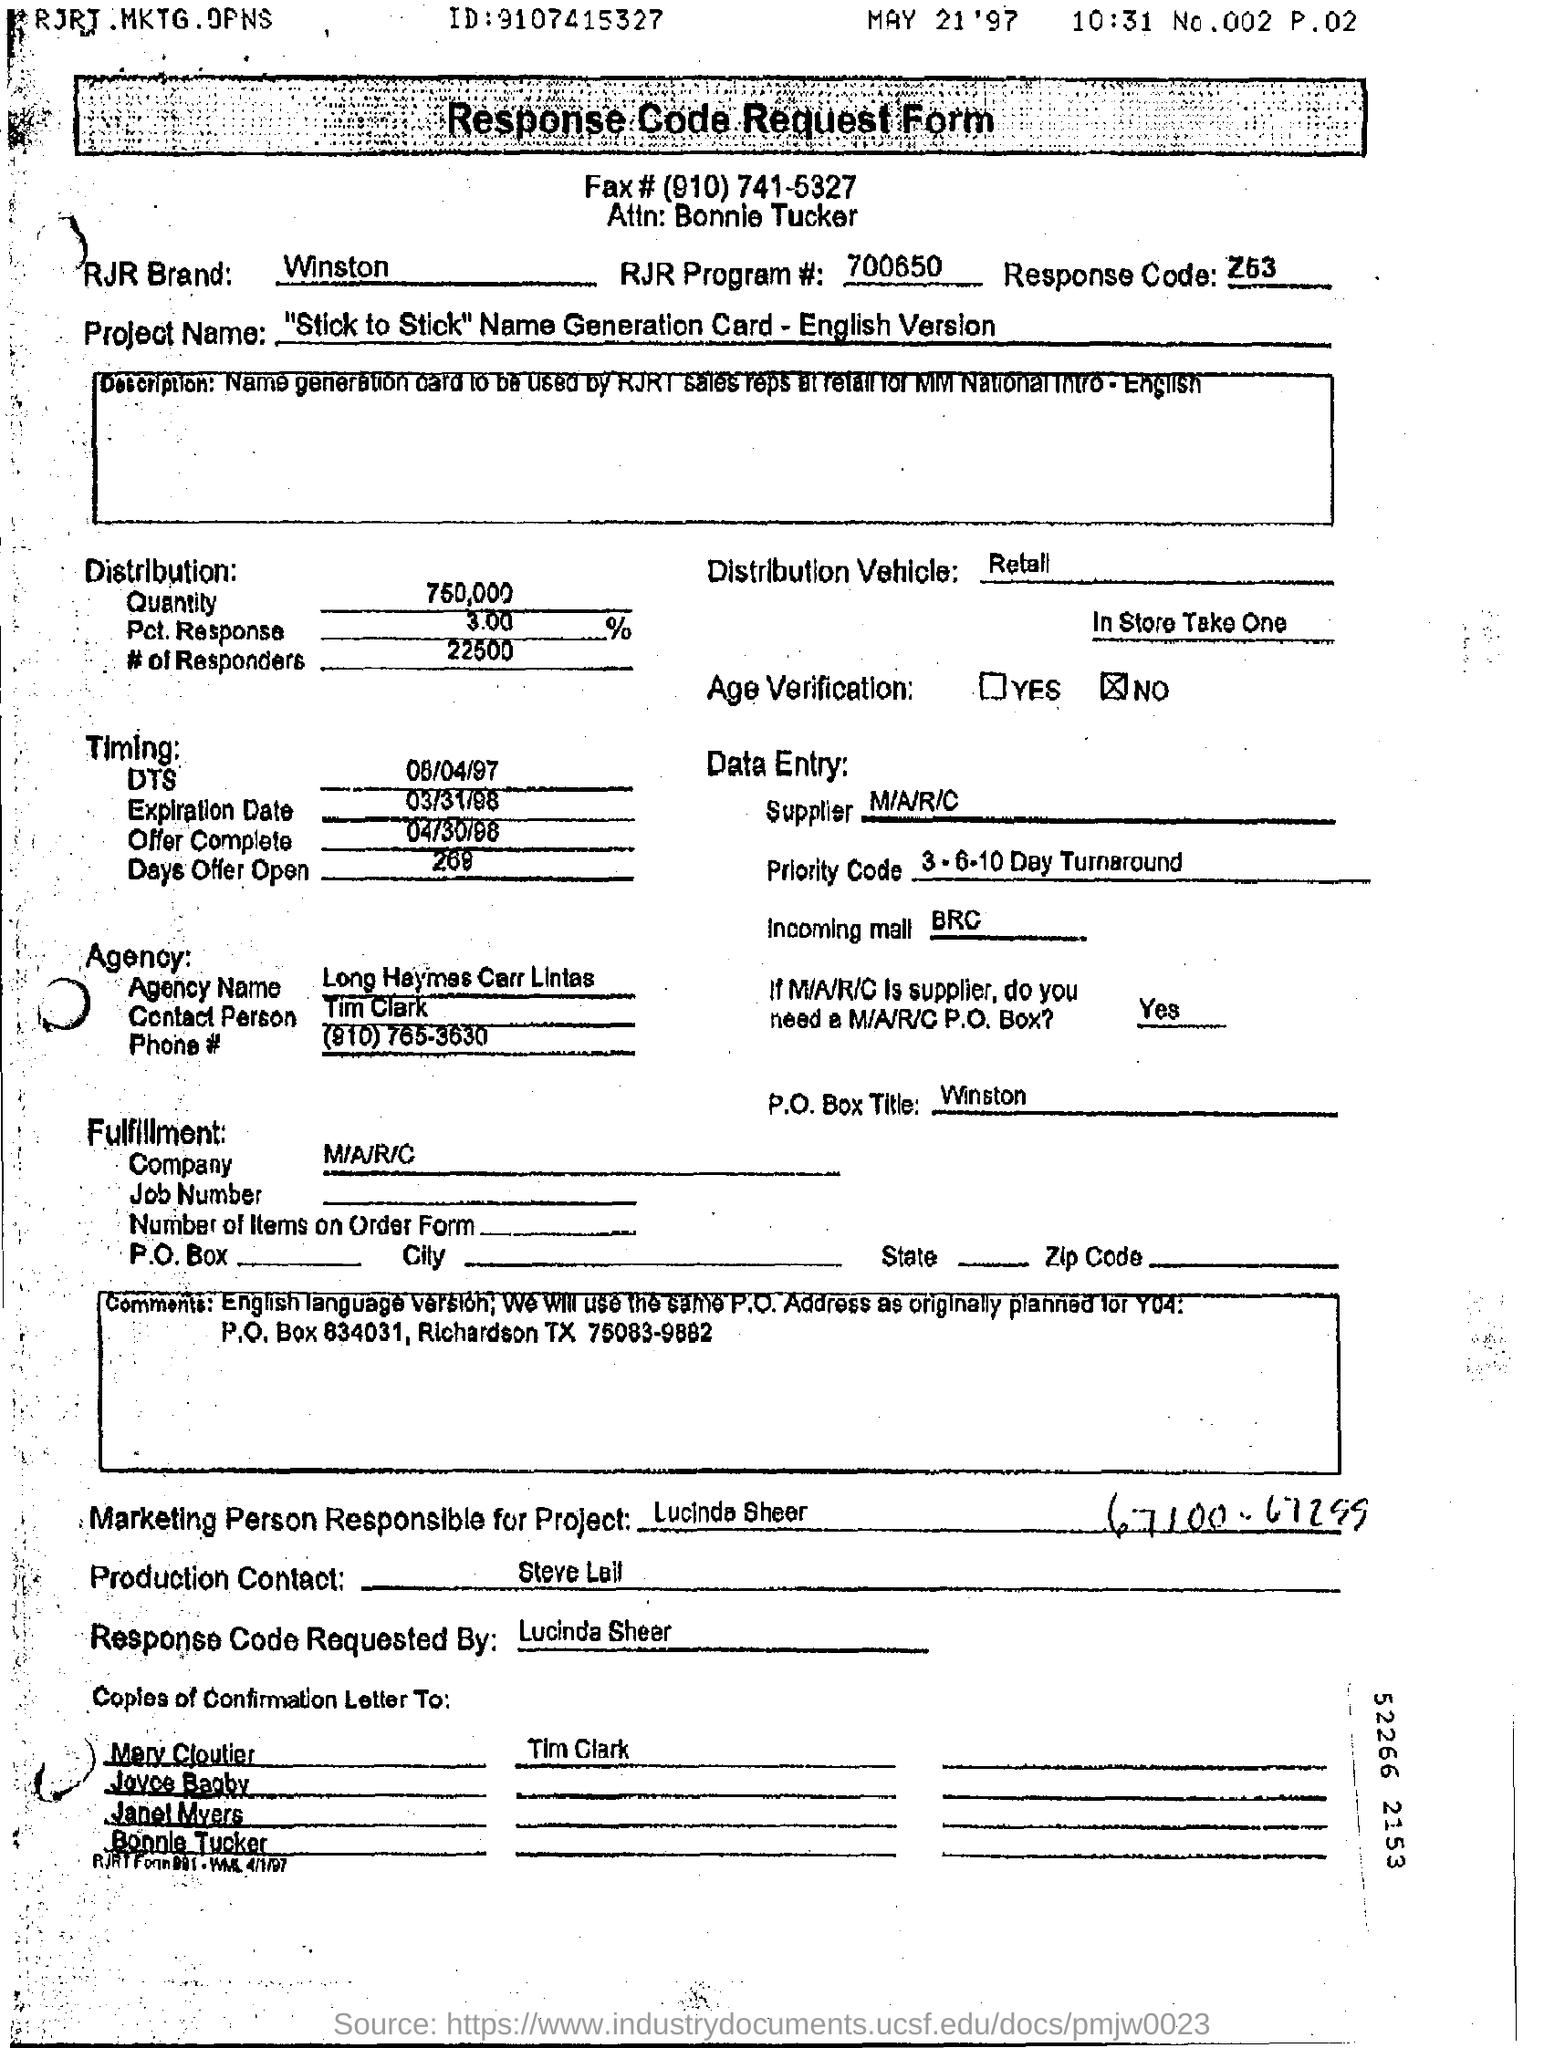Identify some key points in this picture. The marketing person responsible for the project is Lucinda Sheer. The response code is requested by Lucinda Sheer. The Project Name is "Stick to Stick” Name Generation Card - English Version. 